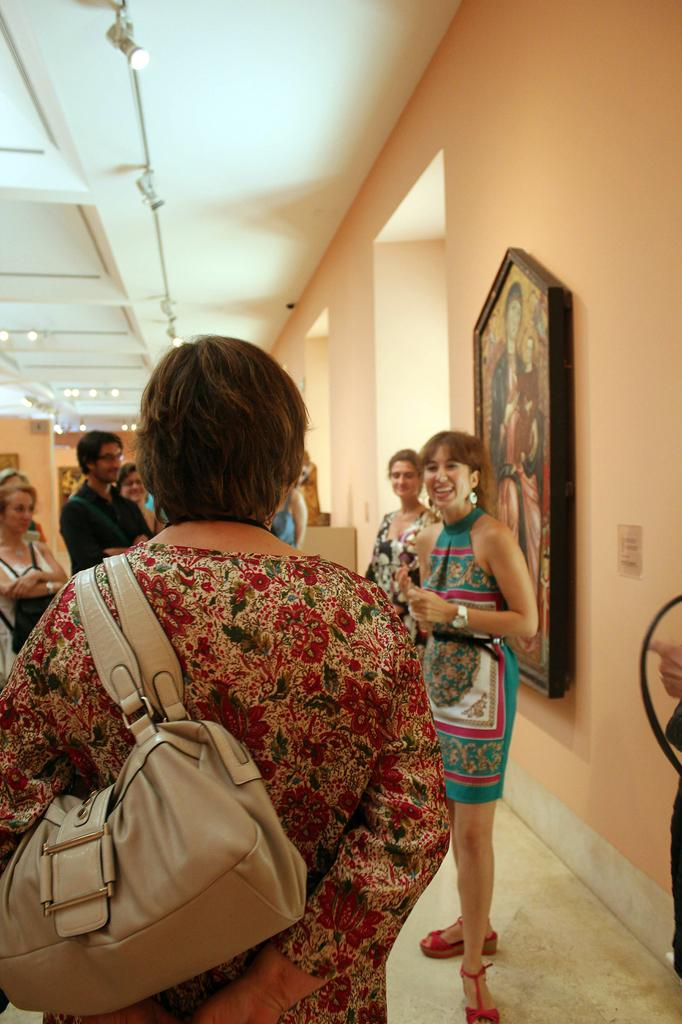How many people are in the image? There are people in the image, but the exact number is not specified. What is one person doing in the image? One person is carrying a bag. What can be seen on the wall in the image? There is a frame on the wall. What is visible at the top of the image? Lights are visible at the top of the image. What type of cushion is being used by the person wearing a vest in the image? There is no mention of a cushion or a person wearing a vest in the image. 